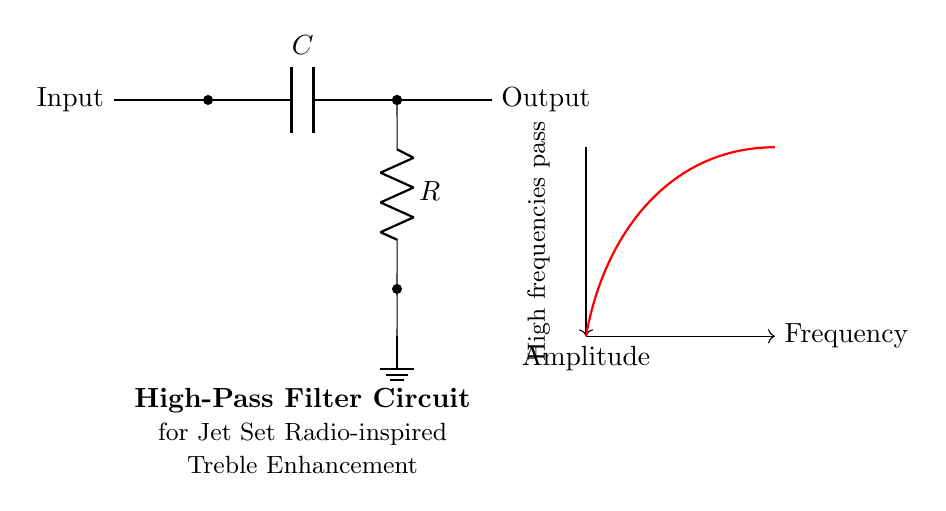What type of filter is represented in the circuit? The circuit is a high-pass filter, as indicated by the arrangement and the functional purpose of passing high frequencies while blocking low frequencies.
Answer: High-pass filter What components are used in this circuit? The circuit consists of a capacitor and a resistor, which are the essential components that create the filtering effect.
Answer: Capacitor and resistor Where does the output signal come from in the circuit? The output signal is taken from the junction between the capacitor and the resistor, which is where the high-frequency signals are allowed to pass through.
Answer: From the capacitor-resistor junction What happens to high frequencies in this circuit? High frequencies are allowed to pass through the circuit, while lower frequencies are attenuated, as described by the frequency response shown in the diagram.
Answer: They pass through What is the effect of increasing the value of the capacitor in this circuit? Increasing the capacitance allows lower cutoff frequencies, which means more low frequencies will be filtered less effectively, while high frequencies still pass through efficiently.
Answer: Low frequencies filtered less What is the function of the resistor in this high-pass filter? The resistor sets the time constant together with the capacitor, determining the cutoff frequency of the high-pass filter and influences how quickly the circuit responds to changes in signal frequency.
Answer: Sets cutoff frequency 